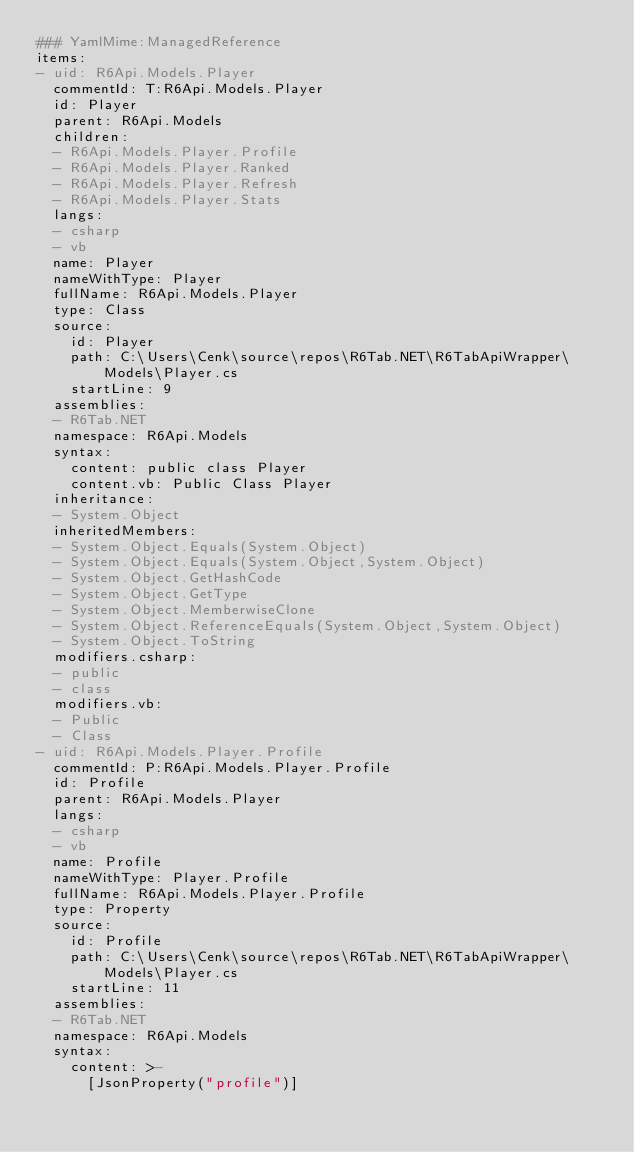<code> <loc_0><loc_0><loc_500><loc_500><_YAML_>### YamlMime:ManagedReference
items:
- uid: R6Api.Models.Player
  commentId: T:R6Api.Models.Player
  id: Player
  parent: R6Api.Models
  children:
  - R6Api.Models.Player.Profile
  - R6Api.Models.Player.Ranked
  - R6Api.Models.Player.Refresh
  - R6Api.Models.Player.Stats
  langs:
  - csharp
  - vb
  name: Player
  nameWithType: Player
  fullName: R6Api.Models.Player
  type: Class
  source:
    id: Player
    path: C:\Users\Cenk\source\repos\R6Tab.NET\R6TabApiWrapper\Models\Player.cs
    startLine: 9
  assemblies:
  - R6Tab.NET
  namespace: R6Api.Models
  syntax:
    content: public class Player
    content.vb: Public Class Player
  inheritance:
  - System.Object
  inheritedMembers:
  - System.Object.Equals(System.Object)
  - System.Object.Equals(System.Object,System.Object)
  - System.Object.GetHashCode
  - System.Object.GetType
  - System.Object.MemberwiseClone
  - System.Object.ReferenceEquals(System.Object,System.Object)
  - System.Object.ToString
  modifiers.csharp:
  - public
  - class
  modifiers.vb:
  - Public
  - Class
- uid: R6Api.Models.Player.Profile
  commentId: P:R6Api.Models.Player.Profile
  id: Profile
  parent: R6Api.Models.Player
  langs:
  - csharp
  - vb
  name: Profile
  nameWithType: Player.Profile
  fullName: R6Api.Models.Player.Profile
  type: Property
  source:
    id: Profile
    path: C:\Users\Cenk\source\repos\R6Tab.NET\R6TabApiWrapper\Models\Player.cs
    startLine: 11
  assemblies:
  - R6Tab.NET
  namespace: R6Api.Models
  syntax:
    content: >-
      [JsonProperty("profile")]
</code> 